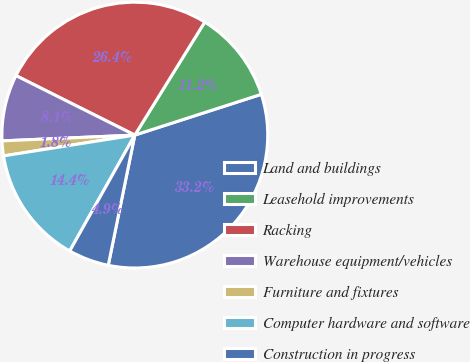Convert chart. <chart><loc_0><loc_0><loc_500><loc_500><pie_chart><fcel>Land and buildings<fcel>Leasehold improvements<fcel>Racking<fcel>Warehouse equipment/vehicles<fcel>Furniture and fixtures<fcel>Computer hardware and software<fcel>Construction in progress<nl><fcel>33.17%<fcel>11.22%<fcel>26.43%<fcel>8.08%<fcel>1.81%<fcel>14.35%<fcel>4.94%<nl></chart> 